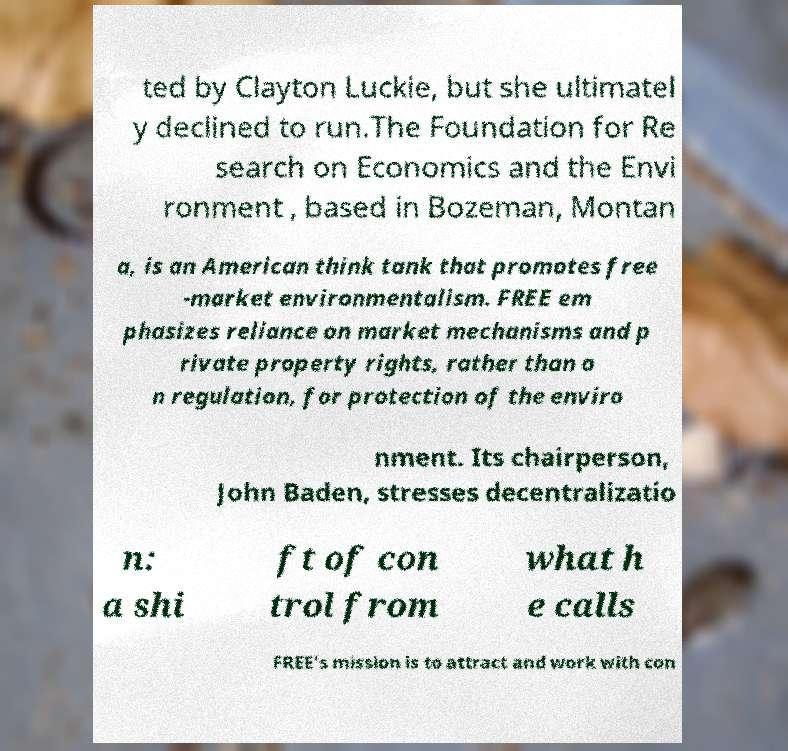Please read and relay the text visible in this image. What does it say? ted by Clayton Luckie, but she ultimatel y declined to run.The Foundation for Re search on Economics and the Envi ronment , based in Bozeman, Montan a, is an American think tank that promotes free -market environmentalism. FREE em phasizes reliance on market mechanisms and p rivate property rights, rather than o n regulation, for protection of the enviro nment. Its chairperson, John Baden, stresses decentralizatio n: a shi ft of con trol from what h e calls FREE's mission is to attract and work with con 